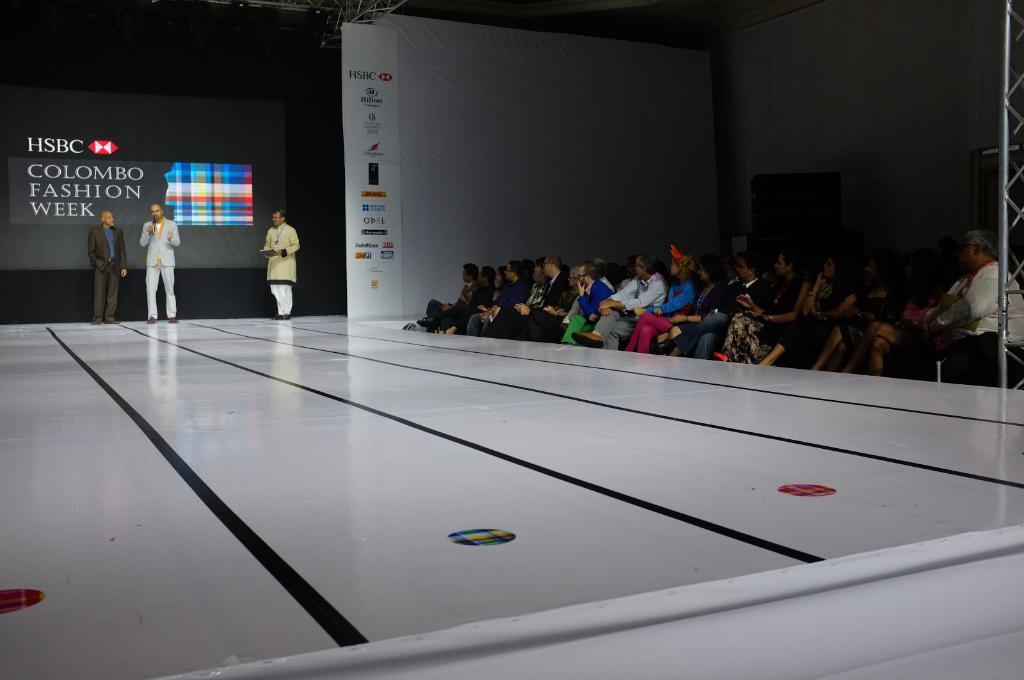What is the man on the left side of the image doing? The man is standing on the left side of the image and talking on a microphone. What can be seen in the image besides the man with the microphone? There is a ramp and people sitting on chairs on the right side of the image. What type of tax is being discussed by the man on the microphone? There is no mention of tax in the image, so it cannot be determined what type of tax is being discussed. 